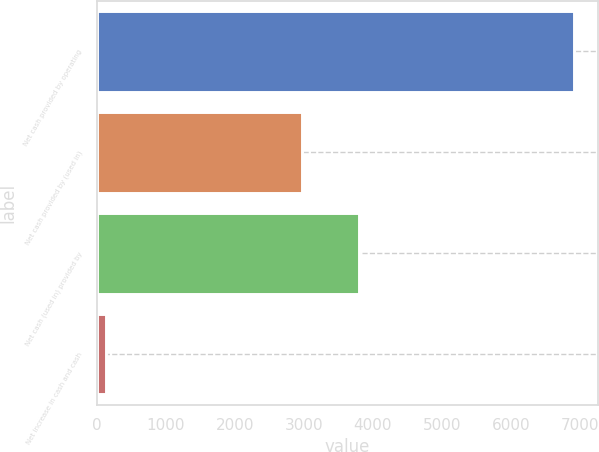Convert chart to OTSL. <chart><loc_0><loc_0><loc_500><loc_500><bar_chart><fcel>Net cash provided by operating<fcel>Net cash provided by (used in)<fcel>Net cash (used in) provided by<fcel>Net increase in cash and cash<nl><fcel>6911<fcel>2974<fcel>3800<fcel>137<nl></chart> 